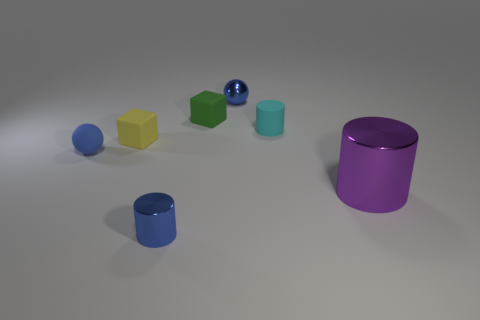Subtract all shiny cylinders. How many cylinders are left? 1 Add 3 yellow blocks. How many objects exist? 10 Subtract all cylinders. How many objects are left? 4 Add 4 large objects. How many large objects are left? 5 Add 2 cubes. How many cubes exist? 4 Subtract 0 cyan balls. How many objects are left? 7 Subtract all cubes. Subtract all balls. How many objects are left? 3 